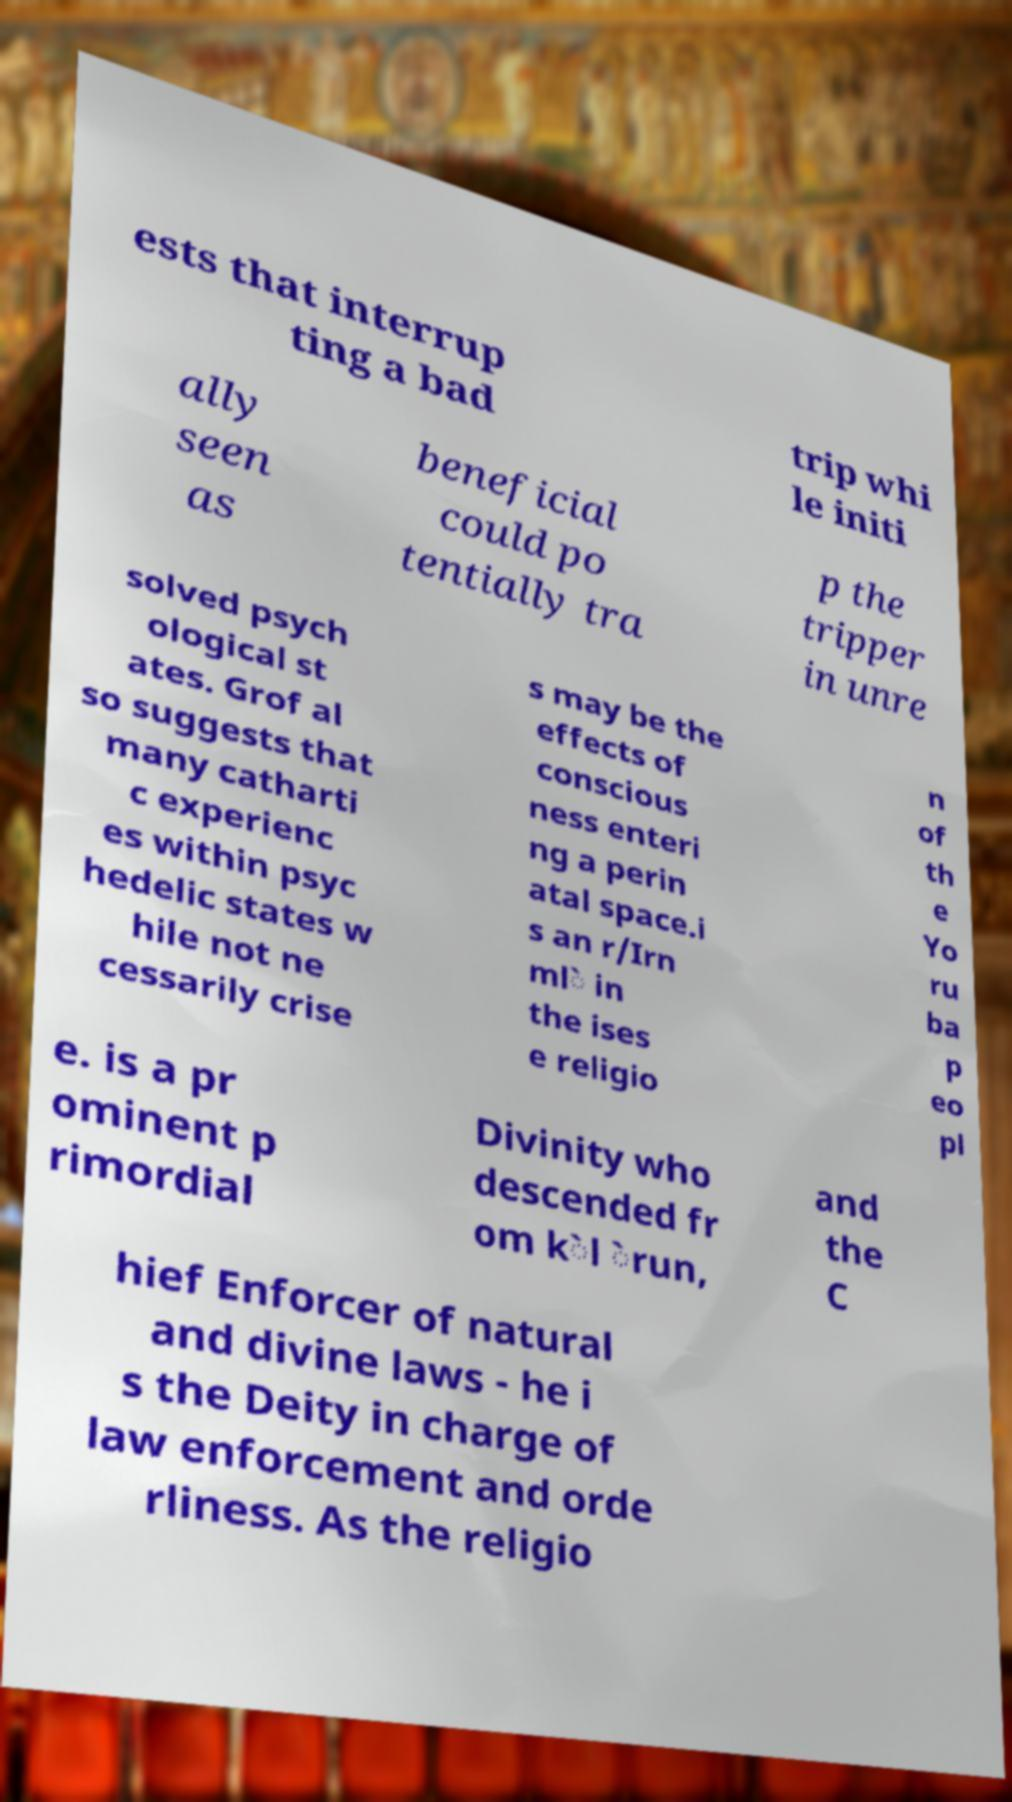Can you read and provide the text displayed in the image?This photo seems to have some interesting text. Can you extract and type it out for me? ests that interrup ting a bad trip whi le initi ally seen as beneficial could po tentially tra p the tripper in unre solved psych ological st ates. Grof al so suggests that many catharti c experienc es within psyc hedelic states w hile not ne cessarily crise s may be the effects of conscious ness enteri ng a perin atal space.i s an r/Irn ml̀ in the ises e religio n of th e Yo ru ba p eo pl e. is a pr ominent p rimordial Divinity who descended fr om k̀l ̀run, and the C hief Enforcer of natural and divine laws - he i s the Deity in charge of law enforcement and orde rliness. As the religio 